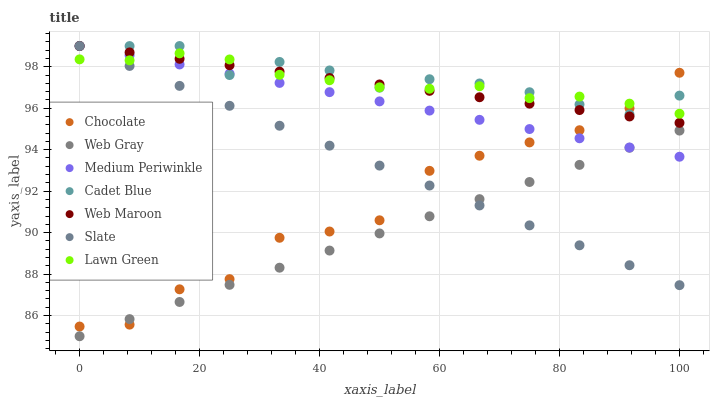Does Web Gray have the minimum area under the curve?
Answer yes or no. Yes. Does Cadet Blue have the maximum area under the curve?
Answer yes or no. Yes. Does Medium Periwinkle have the minimum area under the curve?
Answer yes or no. No. Does Medium Periwinkle have the maximum area under the curve?
Answer yes or no. No. Is Web Maroon the smoothest?
Answer yes or no. Yes. Is Chocolate the roughest?
Answer yes or no. Yes. Is Cadet Blue the smoothest?
Answer yes or no. No. Is Cadet Blue the roughest?
Answer yes or no. No. Does Web Gray have the lowest value?
Answer yes or no. Yes. Does Cadet Blue have the lowest value?
Answer yes or no. No. Does Web Maroon have the highest value?
Answer yes or no. Yes. Does Chocolate have the highest value?
Answer yes or no. No. Is Web Gray less than Cadet Blue?
Answer yes or no. Yes. Is Lawn Green greater than Web Gray?
Answer yes or no. Yes. Does Slate intersect Web Gray?
Answer yes or no. Yes. Is Slate less than Web Gray?
Answer yes or no. No. Is Slate greater than Web Gray?
Answer yes or no. No. Does Web Gray intersect Cadet Blue?
Answer yes or no. No. 